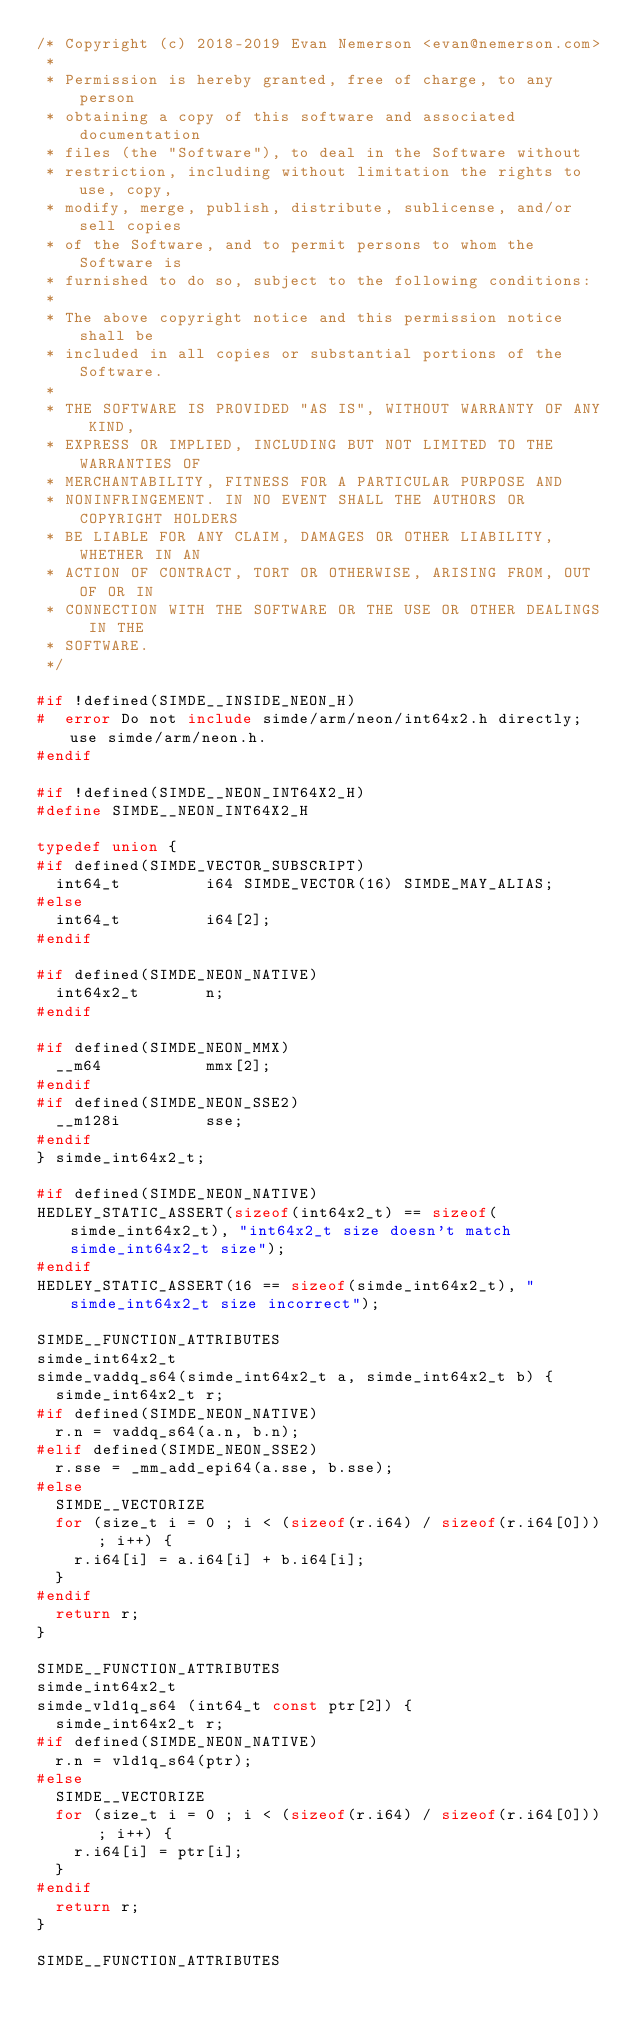<code> <loc_0><loc_0><loc_500><loc_500><_C_>/* Copyright (c) 2018-2019 Evan Nemerson <evan@nemerson.com>
 *
 * Permission is hereby granted, free of charge, to any person
 * obtaining a copy of this software and associated documentation
 * files (the "Software"), to deal in the Software without
 * restriction, including without limitation the rights to use, copy,
 * modify, merge, publish, distribute, sublicense, and/or sell copies
 * of the Software, and to permit persons to whom the Software is
 * furnished to do so, subject to the following conditions:
 *
 * The above copyright notice and this permission notice shall be
 * included in all copies or substantial portions of the Software.
 *
 * THE SOFTWARE IS PROVIDED "AS IS", WITHOUT WARRANTY OF ANY KIND,
 * EXPRESS OR IMPLIED, INCLUDING BUT NOT LIMITED TO THE WARRANTIES OF
 * MERCHANTABILITY, FITNESS FOR A PARTICULAR PURPOSE AND
 * NONINFRINGEMENT. IN NO EVENT SHALL THE AUTHORS OR COPYRIGHT HOLDERS
 * BE LIABLE FOR ANY CLAIM, DAMAGES OR OTHER LIABILITY, WHETHER IN AN
 * ACTION OF CONTRACT, TORT OR OTHERWISE, ARISING FROM, OUT OF OR IN
 * CONNECTION WITH THE SOFTWARE OR THE USE OR OTHER DEALINGS IN THE
 * SOFTWARE.
 */

#if !defined(SIMDE__INSIDE_NEON_H)
#  error Do not include simde/arm/neon/int64x2.h directly; use simde/arm/neon.h.
#endif

#if !defined(SIMDE__NEON_INT64X2_H)
#define SIMDE__NEON_INT64X2_H

typedef union {
#if defined(SIMDE_VECTOR_SUBSCRIPT)
  int64_t         i64 SIMDE_VECTOR(16) SIMDE_MAY_ALIAS;
#else
  int64_t         i64[2];
#endif

#if defined(SIMDE_NEON_NATIVE)
  int64x2_t       n;
#endif

#if defined(SIMDE_NEON_MMX)
  __m64           mmx[2];
#endif
#if defined(SIMDE_NEON_SSE2)
  __m128i         sse;
#endif
} simde_int64x2_t;

#if defined(SIMDE_NEON_NATIVE)
HEDLEY_STATIC_ASSERT(sizeof(int64x2_t) == sizeof(simde_int64x2_t), "int64x2_t size doesn't match simde_int64x2_t size");
#endif
HEDLEY_STATIC_ASSERT(16 == sizeof(simde_int64x2_t), "simde_int64x2_t size incorrect");

SIMDE__FUNCTION_ATTRIBUTES
simde_int64x2_t
simde_vaddq_s64(simde_int64x2_t a, simde_int64x2_t b) {
  simde_int64x2_t r;
#if defined(SIMDE_NEON_NATIVE)
  r.n = vaddq_s64(a.n, b.n);
#elif defined(SIMDE_NEON_SSE2)
  r.sse = _mm_add_epi64(a.sse, b.sse);
#else
  SIMDE__VECTORIZE
  for (size_t i = 0 ; i < (sizeof(r.i64) / sizeof(r.i64[0])) ; i++) {
    r.i64[i] = a.i64[i] + b.i64[i];
  }
#endif
  return r;
}

SIMDE__FUNCTION_ATTRIBUTES
simde_int64x2_t
simde_vld1q_s64 (int64_t const ptr[2]) {
  simde_int64x2_t r;
#if defined(SIMDE_NEON_NATIVE)
  r.n = vld1q_s64(ptr);
#else
  SIMDE__VECTORIZE
  for (size_t i = 0 ; i < (sizeof(r.i64) / sizeof(r.i64[0])) ; i++) {
    r.i64[i] = ptr[i];
  }
#endif
  return r;
}

SIMDE__FUNCTION_ATTRIBUTES</code> 